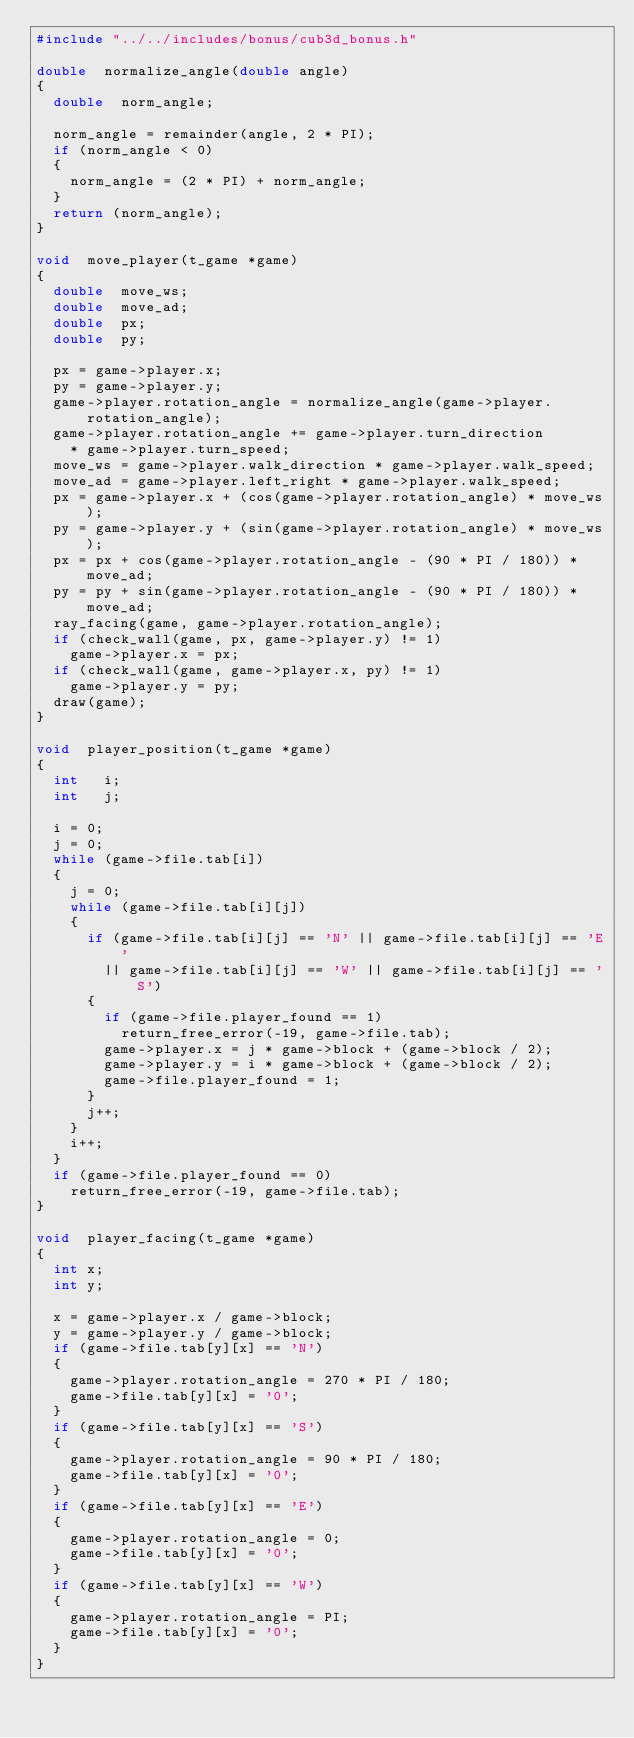<code> <loc_0><loc_0><loc_500><loc_500><_C_>#include "../../includes/bonus/cub3d_bonus.h"

double	normalize_angle(double angle)
{
	double	norm_angle;

	norm_angle = remainder(angle, 2 * PI);
	if (norm_angle < 0)
	{
		norm_angle = (2 * PI) + norm_angle;
	}
	return (norm_angle);
}

void	move_player(t_game *game)
{
	double	move_ws;
	double	move_ad;
	double	px;
	double	py;

	px = game->player.x;
	py = game->player.y;
	game->player.rotation_angle = normalize_angle(game->player.rotation_angle);
	game->player.rotation_angle += game->player.turn_direction
		* game->player.turn_speed;
	move_ws = game->player.walk_direction * game->player.walk_speed;
	move_ad = game->player.left_right * game->player.walk_speed;
	px = game->player.x + (cos(game->player.rotation_angle) * move_ws);
	py = game->player.y + (sin(game->player.rotation_angle) * move_ws);
	px = px + cos(game->player.rotation_angle - (90 * PI / 180)) * move_ad;
	py = py + sin(game->player.rotation_angle - (90 * PI / 180)) * move_ad;
	ray_facing(game, game->player.rotation_angle);
	if (check_wall(game, px, game->player.y) != 1)
		game->player.x = px;
	if (check_wall(game, game->player.x, py) != 1)
		game->player.y = py;
	draw(game);
}

void	player_position(t_game *game)
{
	int		i;
	int		j;

	i = 0;
	j = 0;
	while (game->file.tab[i])
	{
		j = 0;
		while (game->file.tab[i][j])
		{
			if (game->file.tab[i][j] == 'N' || game->file.tab[i][j] == 'E'
				|| game->file.tab[i][j] == 'W' || game->file.tab[i][j] == 'S')
			{
				if (game->file.player_found == 1)
					return_free_error(-19, game->file.tab);
				game->player.x = j * game->block + (game->block / 2);
				game->player.y = i * game->block + (game->block / 2);
				game->file.player_found = 1;
			}
			j++;
		}
		i++;
	}
	if (game->file.player_found == 0)
		return_free_error(-19, game->file.tab);
}

void	player_facing(t_game *game)
{
	int	x;
	int	y;

	x = game->player.x / game->block;
	y = game->player.y / game->block;
	if (game->file.tab[y][x] == 'N')
	{
		game->player.rotation_angle = 270 * PI / 180;
		game->file.tab[y][x] = '0';
	}
	if (game->file.tab[y][x] == 'S')
	{
		game->player.rotation_angle = 90 * PI / 180;
		game->file.tab[y][x] = '0';
	}
	if (game->file.tab[y][x] == 'E')
	{
		game->player.rotation_angle = 0;
		game->file.tab[y][x] = '0';
	}
	if (game->file.tab[y][x] == 'W')
	{
		game->player.rotation_angle = PI;
		game->file.tab[y][x] = '0';
	}
}
</code> 